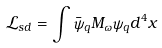Convert formula to latex. <formula><loc_0><loc_0><loc_500><loc_500>\mathcal { L } _ { s d } = \int \bar { \psi } _ { q } M _ { \omega } \psi _ { q } d ^ { 4 } x</formula> 